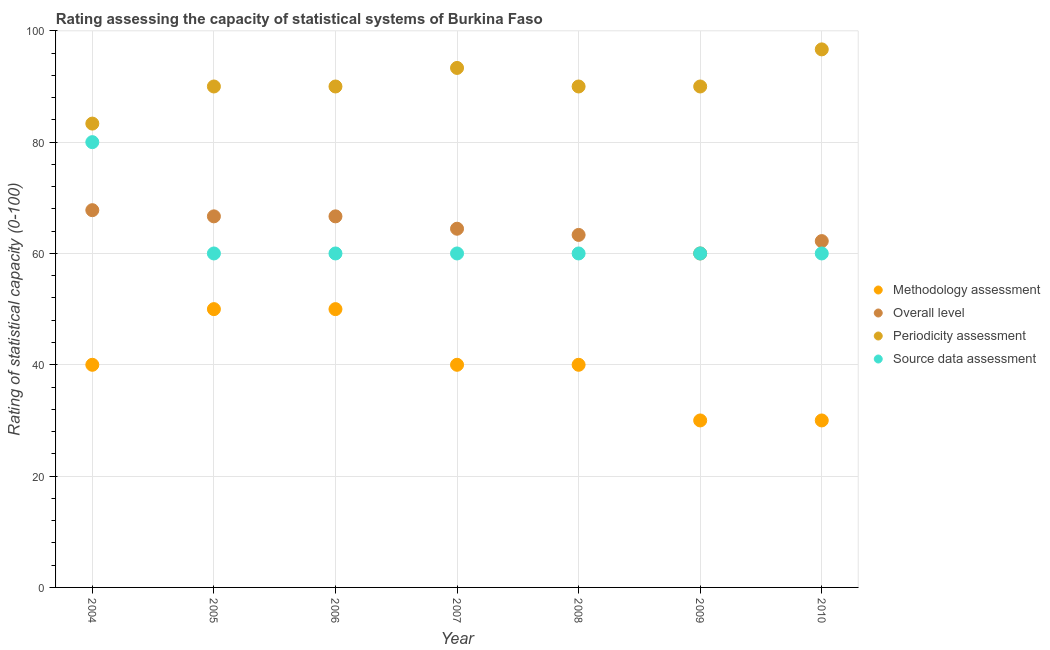Is the number of dotlines equal to the number of legend labels?
Offer a terse response. Yes. What is the periodicity assessment rating in 2008?
Your answer should be very brief. 90. Across all years, what is the maximum periodicity assessment rating?
Ensure brevity in your answer.  96.67. Across all years, what is the minimum methodology assessment rating?
Ensure brevity in your answer.  30. In which year was the source data assessment rating maximum?
Offer a terse response. 2004. In which year was the source data assessment rating minimum?
Your answer should be compact. 2005. What is the total periodicity assessment rating in the graph?
Offer a very short reply. 633.33. What is the difference between the methodology assessment rating in 2004 and that in 2006?
Offer a very short reply. -10. What is the difference between the methodology assessment rating in 2007 and the overall level rating in 2008?
Keep it short and to the point. -23.33. What is the average source data assessment rating per year?
Offer a very short reply. 62.86. In the year 2007, what is the difference between the overall level rating and source data assessment rating?
Give a very brief answer. 4.44. What is the difference between the highest and the second highest methodology assessment rating?
Offer a terse response. 0. What is the difference between the highest and the lowest source data assessment rating?
Make the answer very short. 20. In how many years, is the source data assessment rating greater than the average source data assessment rating taken over all years?
Offer a terse response. 1. Is the sum of the methodology assessment rating in 2006 and 2009 greater than the maximum source data assessment rating across all years?
Provide a short and direct response. No. Is the overall level rating strictly greater than the source data assessment rating over the years?
Ensure brevity in your answer.  No. How many dotlines are there?
Make the answer very short. 4. Does the graph contain any zero values?
Ensure brevity in your answer.  No. Does the graph contain grids?
Offer a terse response. Yes. Where does the legend appear in the graph?
Your answer should be compact. Center right. How many legend labels are there?
Give a very brief answer. 4. How are the legend labels stacked?
Give a very brief answer. Vertical. What is the title of the graph?
Provide a short and direct response. Rating assessing the capacity of statistical systems of Burkina Faso. What is the label or title of the Y-axis?
Offer a very short reply. Rating of statistical capacity (0-100). What is the Rating of statistical capacity (0-100) in Overall level in 2004?
Provide a succinct answer. 67.78. What is the Rating of statistical capacity (0-100) of Periodicity assessment in 2004?
Keep it short and to the point. 83.33. What is the Rating of statistical capacity (0-100) of Overall level in 2005?
Make the answer very short. 66.67. What is the Rating of statistical capacity (0-100) in Periodicity assessment in 2005?
Your answer should be compact. 90. What is the Rating of statistical capacity (0-100) of Source data assessment in 2005?
Make the answer very short. 60. What is the Rating of statistical capacity (0-100) in Overall level in 2006?
Provide a short and direct response. 66.67. What is the Rating of statistical capacity (0-100) of Periodicity assessment in 2006?
Offer a terse response. 90. What is the Rating of statistical capacity (0-100) of Source data assessment in 2006?
Offer a very short reply. 60. What is the Rating of statistical capacity (0-100) of Methodology assessment in 2007?
Keep it short and to the point. 40. What is the Rating of statistical capacity (0-100) in Overall level in 2007?
Offer a terse response. 64.44. What is the Rating of statistical capacity (0-100) of Periodicity assessment in 2007?
Your response must be concise. 93.33. What is the Rating of statistical capacity (0-100) in Overall level in 2008?
Provide a succinct answer. 63.33. What is the Rating of statistical capacity (0-100) of Methodology assessment in 2009?
Ensure brevity in your answer.  30. What is the Rating of statistical capacity (0-100) of Periodicity assessment in 2009?
Provide a short and direct response. 90. What is the Rating of statistical capacity (0-100) of Methodology assessment in 2010?
Offer a terse response. 30. What is the Rating of statistical capacity (0-100) of Overall level in 2010?
Provide a short and direct response. 62.22. What is the Rating of statistical capacity (0-100) in Periodicity assessment in 2010?
Provide a succinct answer. 96.67. Across all years, what is the maximum Rating of statistical capacity (0-100) of Methodology assessment?
Your response must be concise. 50. Across all years, what is the maximum Rating of statistical capacity (0-100) of Overall level?
Make the answer very short. 67.78. Across all years, what is the maximum Rating of statistical capacity (0-100) of Periodicity assessment?
Provide a short and direct response. 96.67. Across all years, what is the maximum Rating of statistical capacity (0-100) of Source data assessment?
Provide a succinct answer. 80. Across all years, what is the minimum Rating of statistical capacity (0-100) of Overall level?
Provide a succinct answer. 60. Across all years, what is the minimum Rating of statistical capacity (0-100) of Periodicity assessment?
Offer a very short reply. 83.33. Across all years, what is the minimum Rating of statistical capacity (0-100) of Source data assessment?
Provide a short and direct response. 60. What is the total Rating of statistical capacity (0-100) in Methodology assessment in the graph?
Provide a succinct answer. 280. What is the total Rating of statistical capacity (0-100) in Overall level in the graph?
Offer a terse response. 451.11. What is the total Rating of statistical capacity (0-100) of Periodicity assessment in the graph?
Offer a terse response. 633.33. What is the total Rating of statistical capacity (0-100) in Source data assessment in the graph?
Offer a very short reply. 440. What is the difference between the Rating of statistical capacity (0-100) of Methodology assessment in 2004 and that in 2005?
Your answer should be very brief. -10. What is the difference between the Rating of statistical capacity (0-100) of Overall level in 2004 and that in 2005?
Your answer should be compact. 1.11. What is the difference between the Rating of statistical capacity (0-100) of Periodicity assessment in 2004 and that in 2005?
Your answer should be very brief. -6.67. What is the difference between the Rating of statistical capacity (0-100) in Overall level in 2004 and that in 2006?
Offer a terse response. 1.11. What is the difference between the Rating of statistical capacity (0-100) of Periodicity assessment in 2004 and that in 2006?
Offer a very short reply. -6.67. What is the difference between the Rating of statistical capacity (0-100) in Source data assessment in 2004 and that in 2006?
Provide a succinct answer. 20. What is the difference between the Rating of statistical capacity (0-100) of Periodicity assessment in 2004 and that in 2007?
Your answer should be very brief. -10. What is the difference between the Rating of statistical capacity (0-100) in Overall level in 2004 and that in 2008?
Provide a succinct answer. 4.44. What is the difference between the Rating of statistical capacity (0-100) in Periodicity assessment in 2004 and that in 2008?
Offer a very short reply. -6.67. What is the difference between the Rating of statistical capacity (0-100) in Methodology assessment in 2004 and that in 2009?
Keep it short and to the point. 10. What is the difference between the Rating of statistical capacity (0-100) in Overall level in 2004 and that in 2009?
Your answer should be very brief. 7.78. What is the difference between the Rating of statistical capacity (0-100) in Periodicity assessment in 2004 and that in 2009?
Make the answer very short. -6.67. What is the difference between the Rating of statistical capacity (0-100) of Source data assessment in 2004 and that in 2009?
Offer a terse response. 20. What is the difference between the Rating of statistical capacity (0-100) in Methodology assessment in 2004 and that in 2010?
Make the answer very short. 10. What is the difference between the Rating of statistical capacity (0-100) of Overall level in 2004 and that in 2010?
Offer a very short reply. 5.56. What is the difference between the Rating of statistical capacity (0-100) of Periodicity assessment in 2004 and that in 2010?
Offer a terse response. -13.33. What is the difference between the Rating of statistical capacity (0-100) of Source data assessment in 2004 and that in 2010?
Offer a very short reply. 20. What is the difference between the Rating of statistical capacity (0-100) of Methodology assessment in 2005 and that in 2006?
Provide a short and direct response. 0. What is the difference between the Rating of statistical capacity (0-100) of Periodicity assessment in 2005 and that in 2006?
Give a very brief answer. 0. What is the difference between the Rating of statistical capacity (0-100) in Source data assessment in 2005 and that in 2006?
Make the answer very short. 0. What is the difference between the Rating of statistical capacity (0-100) in Methodology assessment in 2005 and that in 2007?
Your response must be concise. 10. What is the difference between the Rating of statistical capacity (0-100) in Overall level in 2005 and that in 2007?
Your answer should be very brief. 2.22. What is the difference between the Rating of statistical capacity (0-100) in Overall level in 2005 and that in 2008?
Offer a terse response. 3.33. What is the difference between the Rating of statistical capacity (0-100) in Methodology assessment in 2005 and that in 2009?
Your response must be concise. 20. What is the difference between the Rating of statistical capacity (0-100) in Overall level in 2005 and that in 2009?
Your response must be concise. 6.67. What is the difference between the Rating of statistical capacity (0-100) of Source data assessment in 2005 and that in 2009?
Offer a terse response. 0. What is the difference between the Rating of statistical capacity (0-100) of Methodology assessment in 2005 and that in 2010?
Offer a terse response. 20. What is the difference between the Rating of statistical capacity (0-100) in Overall level in 2005 and that in 2010?
Ensure brevity in your answer.  4.44. What is the difference between the Rating of statistical capacity (0-100) in Periodicity assessment in 2005 and that in 2010?
Your response must be concise. -6.67. What is the difference between the Rating of statistical capacity (0-100) of Source data assessment in 2005 and that in 2010?
Your answer should be compact. 0. What is the difference between the Rating of statistical capacity (0-100) of Overall level in 2006 and that in 2007?
Offer a very short reply. 2.22. What is the difference between the Rating of statistical capacity (0-100) in Periodicity assessment in 2006 and that in 2007?
Your answer should be very brief. -3.33. What is the difference between the Rating of statistical capacity (0-100) of Source data assessment in 2006 and that in 2007?
Provide a succinct answer. 0. What is the difference between the Rating of statistical capacity (0-100) in Methodology assessment in 2006 and that in 2008?
Your answer should be compact. 10. What is the difference between the Rating of statistical capacity (0-100) of Overall level in 2006 and that in 2008?
Provide a short and direct response. 3.33. What is the difference between the Rating of statistical capacity (0-100) in Periodicity assessment in 2006 and that in 2008?
Keep it short and to the point. 0. What is the difference between the Rating of statistical capacity (0-100) of Methodology assessment in 2006 and that in 2009?
Offer a terse response. 20. What is the difference between the Rating of statistical capacity (0-100) of Overall level in 2006 and that in 2009?
Your response must be concise. 6.67. What is the difference between the Rating of statistical capacity (0-100) in Periodicity assessment in 2006 and that in 2009?
Ensure brevity in your answer.  0. What is the difference between the Rating of statistical capacity (0-100) of Source data assessment in 2006 and that in 2009?
Your answer should be compact. 0. What is the difference between the Rating of statistical capacity (0-100) of Methodology assessment in 2006 and that in 2010?
Provide a short and direct response. 20. What is the difference between the Rating of statistical capacity (0-100) in Overall level in 2006 and that in 2010?
Offer a very short reply. 4.44. What is the difference between the Rating of statistical capacity (0-100) in Periodicity assessment in 2006 and that in 2010?
Provide a succinct answer. -6.67. What is the difference between the Rating of statistical capacity (0-100) in Overall level in 2007 and that in 2008?
Provide a succinct answer. 1.11. What is the difference between the Rating of statistical capacity (0-100) in Periodicity assessment in 2007 and that in 2008?
Ensure brevity in your answer.  3.33. What is the difference between the Rating of statistical capacity (0-100) in Overall level in 2007 and that in 2009?
Your answer should be very brief. 4.44. What is the difference between the Rating of statistical capacity (0-100) in Source data assessment in 2007 and that in 2009?
Offer a terse response. 0. What is the difference between the Rating of statistical capacity (0-100) in Overall level in 2007 and that in 2010?
Make the answer very short. 2.22. What is the difference between the Rating of statistical capacity (0-100) in Source data assessment in 2007 and that in 2010?
Offer a very short reply. 0. What is the difference between the Rating of statistical capacity (0-100) in Overall level in 2008 and that in 2010?
Provide a succinct answer. 1.11. What is the difference between the Rating of statistical capacity (0-100) in Periodicity assessment in 2008 and that in 2010?
Offer a terse response. -6.67. What is the difference between the Rating of statistical capacity (0-100) of Source data assessment in 2008 and that in 2010?
Your response must be concise. 0. What is the difference between the Rating of statistical capacity (0-100) of Methodology assessment in 2009 and that in 2010?
Provide a short and direct response. 0. What is the difference between the Rating of statistical capacity (0-100) in Overall level in 2009 and that in 2010?
Offer a terse response. -2.22. What is the difference between the Rating of statistical capacity (0-100) in Periodicity assessment in 2009 and that in 2010?
Make the answer very short. -6.67. What is the difference between the Rating of statistical capacity (0-100) of Methodology assessment in 2004 and the Rating of statistical capacity (0-100) of Overall level in 2005?
Make the answer very short. -26.67. What is the difference between the Rating of statistical capacity (0-100) in Overall level in 2004 and the Rating of statistical capacity (0-100) in Periodicity assessment in 2005?
Make the answer very short. -22.22. What is the difference between the Rating of statistical capacity (0-100) in Overall level in 2004 and the Rating of statistical capacity (0-100) in Source data assessment in 2005?
Your answer should be compact. 7.78. What is the difference between the Rating of statistical capacity (0-100) in Periodicity assessment in 2004 and the Rating of statistical capacity (0-100) in Source data assessment in 2005?
Offer a very short reply. 23.33. What is the difference between the Rating of statistical capacity (0-100) of Methodology assessment in 2004 and the Rating of statistical capacity (0-100) of Overall level in 2006?
Give a very brief answer. -26.67. What is the difference between the Rating of statistical capacity (0-100) in Overall level in 2004 and the Rating of statistical capacity (0-100) in Periodicity assessment in 2006?
Your response must be concise. -22.22. What is the difference between the Rating of statistical capacity (0-100) in Overall level in 2004 and the Rating of statistical capacity (0-100) in Source data assessment in 2006?
Provide a succinct answer. 7.78. What is the difference between the Rating of statistical capacity (0-100) of Periodicity assessment in 2004 and the Rating of statistical capacity (0-100) of Source data assessment in 2006?
Provide a succinct answer. 23.33. What is the difference between the Rating of statistical capacity (0-100) of Methodology assessment in 2004 and the Rating of statistical capacity (0-100) of Overall level in 2007?
Offer a very short reply. -24.44. What is the difference between the Rating of statistical capacity (0-100) in Methodology assessment in 2004 and the Rating of statistical capacity (0-100) in Periodicity assessment in 2007?
Keep it short and to the point. -53.33. What is the difference between the Rating of statistical capacity (0-100) in Overall level in 2004 and the Rating of statistical capacity (0-100) in Periodicity assessment in 2007?
Give a very brief answer. -25.56. What is the difference between the Rating of statistical capacity (0-100) in Overall level in 2004 and the Rating of statistical capacity (0-100) in Source data assessment in 2007?
Keep it short and to the point. 7.78. What is the difference between the Rating of statistical capacity (0-100) in Periodicity assessment in 2004 and the Rating of statistical capacity (0-100) in Source data assessment in 2007?
Offer a very short reply. 23.33. What is the difference between the Rating of statistical capacity (0-100) in Methodology assessment in 2004 and the Rating of statistical capacity (0-100) in Overall level in 2008?
Offer a terse response. -23.33. What is the difference between the Rating of statistical capacity (0-100) of Methodology assessment in 2004 and the Rating of statistical capacity (0-100) of Periodicity assessment in 2008?
Keep it short and to the point. -50. What is the difference between the Rating of statistical capacity (0-100) in Methodology assessment in 2004 and the Rating of statistical capacity (0-100) in Source data assessment in 2008?
Provide a succinct answer. -20. What is the difference between the Rating of statistical capacity (0-100) in Overall level in 2004 and the Rating of statistical capacity (0-100) in Periodicity assessment in 2008?
Keep it short and to the point. -22.22. What is the difference between the Rating of statistical capacity (0-100) in Overall level in 2004 and the Rating of statistical capacity (0-100) in Source data assessment in 2008?
Offer a very short reply. 7.78. What is the difference between the Rating of statistical capacity (0-100) of Periodicity assessment in 2004 and the Rating of statistical capacity (0-100) of Source data assessment in 2008?
Offer a very short reply. 23.33. What is the difference between the Rating of statistical capacity (0-100) in Methodology assessment in 2004 and the Rating of statistical capacity (0-100) in Overall level in 2009?
Provide a short and direct response. -20. What is the difference between the Rating of statistical capacity (0-100) in Overall level in 2004 and the Rating of statistical capacity (0-100) in Periodicity assessment in 2009?
Your answer should be compact. -22.22. What is the difference between the Rating of statistical capacity (0-100) in Overall level in 2004 and the Rating of statistical capacity (0-100) in Source data assessment in 2009?
Offer a terse response. 7.78. What is the difference between the Rating of statistical capacity (0-100) in Periodicity assessment in 2004 and the Rating of statistical capacity (0-100) in Source data assessment in 2009?
Offer a very short reply. 23.33. What is the difference between the Rating of statistical capacity (0-100) in Methodology assessment in 2004 and the Rating of statistical capacity (0-100) in Overall level in 2010?
Keep it short and to the point. -22.22. What is the difference between the Rating of statistical capacity (0-100) in Methodology assessment in 2004 and the Rating of statistical capacity (0-100) in Periodicity assessment in 2010?
Your answer should be compact. -56.67. What is the difference between the Rating of statistical capacity (0-100) of Overall level in 2004 and the Rating of statistical capacity (0-100) of Periodicity assessment in 2010?
Make the answer very short. -28.89. What is the difference between the Rating of statistical capacity (0-100) in Overall level in 2004 and the Rating of statistical capacity (0-100) in Source data assessment in 2010?
Provide a succinct answer. 7.78. What is the difference between the Rating of statistical capacity (0-100) in Periodicity assessment in 2004 and the Rating of statistical capacity (0-100) in Source data assessment in 2010?
Keep it short and to the point. 23.33. What is the difference between the Rating of statistical capacity (0-100) in Methodology assessment in 2005 and the Rating of statistical capacity (0-100) in Overall level in 2006?
Make the answer very short. -16.67. What is the difference between the Rating of statistical capacity (0-100) in Methodology assessment in 2005 and the Rating of statistical capacity (0-100) in Source data assessment in 2006?
Ensure brevity in your answer.  -10. What is the difference between the Rating of statistical capacity (0-100) of Overall level in 2005 and the Rating of statistical capacity (0-100) of Periodicity assessment in 2006?
Offer a very short reply. -23.33. What is the difference between the Rating of statistical capacity (0-100) in Periodicity assessment in 2005 and the Rating of statistical capacity (0-100) in Source data assessment in 2006?
Make the answer very short. 30. What is the difference between the Rating of statistical capacity (0-100) of Methodology assessment in 2005 and the Rating of statistical capacity (0-100) of Overall level in 2007?
Your response must be concise. -14.44. What is the difference between the Rating of statistical capacity (0-100) in Methodology assessment in 2005 and the Rating of statistical capacity (0-100) in Periodicity assessment in 2007?
Provide a succinct answer. -43.33. What is the difference between the Rating of statistical capacity (0-100) in Methodology assessment in 2005 and the Rating of statistical capacity (0-100) in Source data assessment in 2007?
Your answer should be compact. -10. What is the difference between the Rating of statistical capacity (0-100) in Overall level in 2005 and the Rating of statistical capacity (0-100) in Periodicity assessment in 2007?
Keep it short and to the point. -26.67. What is the difference between the Rating of statistical capacity (0-100) in Overall level in 2005 and the Rating of statistical capacity (0-100) in Source data assessment in 2007?
Your answer should be very brief. 6.67. What is the difference between the Rating of statistical capacity (0-100) in Methodology assessment in 2005 and the Rating of statistical capacity (0-100) in Overall level in 2008?
Make the answer very short. -13.33. What is the difference between the Rating of statistical capacity (0-100) of Overall level in 2005 and the Rating of statistical capacity (0-100) of Periodicity assessment in 2008?
Offer a very short reply. -23.33. What is the difference between the Rating of statistical capacity (0-100) of Methodology assessment in 2005 and the Rating of statistical capacity (0-100) of Overall level in 2009?
Make the answer very short. -10. What is the difference between the Rating of statistical capacity (0-100) of Methodology assessment in 2005 and the Rating of statistical capacity (0-100) of Source data assessment in 2009?
Keep it short and to the point. -10. What is the difference between the Rating of statistical capacity (0-100) in Overall level in 2005 and the Rating of statistical capacity (0-100) in Periodicity assessment in 2009?
Make the answer very short. -23.33. What is the difference between the Rating of statistical capacity (0-100) of Overall level in 2005 and the Rating of statistical capacity (0-100) of Source data assessment in 2009?
Provide a succinct answer. 6.67. What is the difference between the Rating of statistical capacity (0-100) of Methodology assessment in 2005 and the Rating of statistical capacity (0-100) of Overall level in 2010?
Offer a terse response. -12.22. What is the difference between the Rating of statistical capacity (0-100) of Methodology assessment in 2005 and the Rating of statistical capacity (0-100) of Periodicity assessment in 2010?
Provide a short and direct response. -46.67. What is the difference between the Rating of statistical capacity (0-100) in Methodology assessment in 2005 and the Rating of statistical capacity (0-100) in Source data assessment in 2010?
Provide a short and direct response. -10. What is the difference between the Rating of statistical capacity (0-100) in Periodicity assessment in 2005 and the Rating of statistical capacity (0-100) in Source data assessment in 2010?
Make the answer very short. 30. What is the difference between the Rating of statistical capacity (0-100) in Methodology assessment in 2006 and the Rating of statistical capacity (0-100) in Overall level in 2007?
Your answer should be compact. -14.44. What is the difference between the Rating of statistical capacity (0-100) of Methodology assessment in 2006 and the Rating of statistical capacity (0-100) of Periodicity assessment in 2007?
Ensure brevity in your answer.  -43.33. What is the difference between the Rating of statistical capacity (0-100) in Methodology assessment in 2006 and the Rating of statistical capacity (0-100) in Source data assessment in 2007?
Offer a terse response. -10. What is the difference between the Rating of statistical capacity (0-100) of Overall level in 2006 and the Rating of statistical capacity (0-100) of Periodicity assessment in 2007?
Keep it short and to the point. -26.67. What is the difference between the Rating of statistical capacity (0-100) in Overall level in 2006 and the Rating of statistical capacity (0-100) in Source data assessment in 2007?
Your answer should be very brief. 6.67. What is the difference between the Rating of statistical capacity (0-100) in Methodology assessment in 2006 and the Rating of statistical capacity (0-100) in Overall level in 2008?
Make the answer very short. -13.33. What is the difference between the Rating of statistical capacity (0-100) in Methodology assessment in 2006 and the Rating of statistical capacity (0-100) in Periodicity assessment in 2008?
Your answer should be compact. -40. What is the difference between the Rating of statistical capacity (0-100) in Overall level in 2006 and the Rating of statistical capacity (0-100) in Periodicity assessment in 2008?
Keep it short and to the point. -23.33. What is the difference between the Rating of statistical capacity (0-100) of Overall level in 2006 and the Rating of statistical capacity (0-100) of Source data assessment in 2008?
Make the answer very short. 6.67. What is the difference between the Rating of statistical capacity (0-100) in Periodicity assessment in 2006 and the Rating of statistical capacity (0-100) in Source data assessment in 2008?
Provide a succinct answer. 30. What is the difference between the Rating of statistical capacity (0-100) in Methodology assessment in 2006 and the Rating of statistical capacity (0-100) in Periodicity assessment in 2009?
Provide a short and direct response. -40. What is the difference between the Rating of statistical capacity (0-100) in Methodology assessment in 2006 and the Rating of statistical capacity (0-100) in Source data assessment in 2009?
Offer a very short reply. -10. What is the difference between the Rating of statistical capacity (0-100) in Overall level in 2006 and the Rating of statistical capacity (0-100) in Periodicity assessment in 2009?
Your answer should be compact. -23.33. What is the difference between the Rating of statistical capacity (0-100) of Methodology assessment in 2006 and the Rating of statistical capacity (0-100) of Overall level in 2010?
Offer a very short reply. -12.22. What is the difference between the Rating of statistical capacity (0-100) in Methodology assessment in 2006 and the Rating of statistical capacity (0-100) in Periodicity assessment in 2010?
Offer a very short reply. -46.67. What is the difference between the Rating of statistical capacity (0-100) of Methodology assessment in 2006 and the Rating of statistical capacity (0-100) of Source data assessment in 2010?
Your answer should be compact. -10. What is the difference between the Rating of statistical capacity (0-100) of Overall level in 2006 and the Rating of statistical capacity (0-100) of Source data assessment in 2010?
Offer a very short reply. 6.67. What is the difference between the Rating of statistical capacity (0-100) in Methodology assessment in 2007 and the Rating of statistical capacity (0-100) in Overall level in 2008?
Ensure brevity in your answer.  -23.33. What is the difference between the Rating of statistical capacity (0-100) of Methodology assessment in 2007 and the Rating of statistical capacity (0-100) of Periodicity assessment in 2008?
Keep it short and to the point. -50. What is the difference between the Rating of statistical capacity (0-100) in Overall level in 2007 and the Rating of statistical capacity (0-100) in Periodicity assessment in 2008?
Keep it short and to the point. -25.56. What is the difference between the Rating of statistical capacity (0-100) of Overall level in 2007 and the Rating of statistical capacity (0-100) of Source data assessment in 2008?
Your answer should be compact. 4.44. What is the difference between the Rating of statistical capacity (0-100) of Periodicity assessment in 2007 and the Rating of statistical capacity (0-100) of Source data assessment in 2008?
Offer a terse response. 33.33. What is the difference between the Rating of statistical capacity (0-100) in Methodology assessment in 2007 and the Rating of statistical capacity (0-100) in Overall level in 2009?
Ensure brevity in your answer.  -20. What is the difference between the Rating of statistical capacity (0-100) of Methodology assessment in 2007 and the Rating of statistical capacity (0-100) of Periodicity assessment in 2009?
Make the answer very short. -50. What is the difference between the Rating of statistical capacity (0-100) in Methodology assessment in 2007 and the Rating of statistical capacity (0-100) in Source data assessment in 2009?
Provide a succinct answer. -20. What is the difference between the Rating of statistical capacity (0-100) in Overall level in 2007 and the Rating of statistical capacity (0-100) in Periodicity assessment in 2009?
Make the answer very short. -25.56. What is the difference between the Rating of statistical capacity (0-100) of Overall level in 2007 and the Rating of statistical capacity (0-100) of Source data assessment in 2009?
Your response must be concise. 4.44. What is the difference between the Rating of statistical capacity (0-100) of Periodicity assessment in 2007 and the Rating of statistical capacity (0-100) of Source data assessment in 2009?
Offer a very short reply. 33.33. What is the difference between the Rating of statistical capacity (0-100) of Methodology assessment in 2007 and the Rating of statistical capacity (0-100) of Overall level in 2010?
Provide a succinct answer. -22.22. What is the difference between the Rating of statistical capacity (0-100) in Methodology assessment in 2007 and the Rating of statistical capacity (0-100) in Periodicity assessment in 2010?
Provide a succinct answer. -56.67. What is the difference between the Rating of statistical capacity (0-100) in Methodology assessment in 2007 and the Rating of statistical capacity (0-100) in Source data assessment in 2010?
Keep it short and to the point. -20. What is the difference between the Rating of statistical capacity (0-100) in Overall level in 2007 and the Rating of statistical capacity (0-100) in Periodicity assessment in 2010?
Provide a succinct answer. -32.22. What is the difference between the Rating of statistical capacity (0-100) of Overall level in 2007 and the Rating of statistical capacity (0-100) of Source data assessment in 2010?
Make the answer very short. 4.44. What is the difference between the Rating of statistical capacity (0-100) in Periodicity assessment in 2007 and the Rating of statistical capacity (0-100) in Source data assessment in 2010?
Make the answer very short. 33.33. What is the difference between the Rating of statistical capacity (0-100) in Methodology assessment in 2008 and the Rating of statistical capacity (0-100) in Periodicity assessment in 2009?
Offer a very short reply. -50. What is the difference between the Rating of statistical capacity (0-100) of Methodology assessment in 2008 and the Rating of statistical capacity (0-100) of Source data assessment in 2009?
Your response must be concise. -20. What is the difference between the Rating of statistical capacity (0-100) of Overall level in 2008 and the Rating of statistical capacity (0-100) of Periodicity assessment in 2009?
Offer a very short reply. -26.67. What is the difference between the Rating of statistical capacity (0-100) in Methodology assessment in 2008 and the Rating of statistical capacity (0-100) in Overall level in 2010?
Your answer should be compact. -22.22. What is the difference between the Rating of statistical capacity (0-100) of Methodology assessment in 2008 and the Rating of statistical capacity (0-100) of Periodicity assessment in 2010?
Provide a succinct answer. -56.67. What is the difference between the Rating of statistical capacity (0-100) of Methodology assessment in 2008 and the Rating of statistical capacity (0-100) of Source data assessment in 2010?
Provide a short and direct response. -20. What is the difference between the Rating of statistical capacity (0-100) of Overall level in 2008 and the Rating of statistical capacity (0-100) of Periodicity assessment in 2010?
Make the answer very short. -33.33. What is the difference between the Rating of statistical capacity (0-100) in Overall level in 2008 and the Rating of statistical capacity (0-100) in Source data assessment in 2010?
Your answer should be very brief. 3.33. What is the difference between the Rating of statistical capacity (0-100) of Methodology assessment in 2009 and the Rating of statistical capacity (0-100) of Overall level in 2010?
Offer a terse response. -32.22. What is the difference between the Rating of statistical capacity (0-100) in Methodology assessment in 2009 and the Rating of statistical capacity (0-100) in Periodicity assessment in 2010?
Offer a very short reply. -66.67. What is the difference between the Rating of statistical capacity (0-100) of Overall level in 2009 and the Rating of statistical capacity (0-100) of Periodicity assessment in 2010?
Your answer should be very brief. -36.67. What is the difference between the Rating of statistical capacity (0-100) of Overall level in 2009 and the Rating of statistical capacity (0-100) of Source data assessment in 2010?
Offer a terse response. 0. What is the difference between the Rating of statistical capacity (0-100) in Periodicity assessment in 2009 and the Rating of statistical capacity (0-100) in Source data assessment in 2010?
Your response must be concise. 30. What is the average Rating of statistical capacity (0-100) in Overall level per year?
Offer a very short reply. 64.44. What is the average Rating of statistical capacity (0-100) in Periodicity assessment per year?
Your response must be concise. 90.48. What is the average Rating of statistical capacity (0-100) of Source data assessment per year?
Keep it short and to the point. 62.86. In the year 2004, what is the difference between the Rating of statistical capacity (0-100) in Methodology assessment and Rating of statistical capacity (0-100) in Overall level?
Your response must be concise. -27.78. In the year 2004, what is the difference between the Rating of statistical capacity (0-100) in Methodology assessment and Rating of statistical capacity (0-100) in Periodicity assessment?
Offer a very short reply. -43.33. In the year 2004, what is the difference between the Rating of statistical capacity (0-100) in Methodology assessment and Rating of statistical capacity (0-100) in Source data assessment?
Keep it short and to the point. -40. In the year 2004, what is the difference between the Rating of statistical capacity (0-100) of Overall level and Rating of statistical capacity (0-100) of Periodicity assessment?
Make the answer very short. -15.56. In the year 2004, what is the difference between the Rating of statistical capacity (0-100) in Overall level and Rating of statistical capacity (0-100) in Source data assessment?
Offer a terse response. -12.22. In the year 2004, what is the difference between the Rating of statistical capacity (0-100) of Periodicity assessment and Rating of statistical capacity (0-100) of Source data assessment?
Provide a succinct answer. 3.33. In the year 2005, what is the difference between the Rating of statistical capacity (0-100) in Methodology assessment and Rating of statistical capacity (0-100) in Overall level?
Your answer should be very brief. -16.67. In the year 2005, what is the difference between the Rating of statistical capacity (0-100) in Methodology assessment and Rating of statistical capacity (0-100) in Source data assessment?
Your answer should be very brief. -10. In the year 2005, what is the difference between the Rating of statistical capacity (0-100) of Overall level and Rating of statistical capacity (0-100) of Periodicity assessment?
Give a very brief answer. -23.33. In the year 2005, what is the difference between the Rating of statistical capacity (0-100) in Overall level and Rating of statistical capacity (0-100) in Source data assessment?
Your response must be concise. 6.67. In the year 2005, what is the difference between the Rating of statistical capacity (0-100) in Periodicity assessment and Rating of statistical capacity (0-100) in Source data assessment?
Your answer should be compact. 30. In the year 2006, what is the difference between the Rating of statistical capacity (0-100) in Methodology assessment and Rating of statistical capacity (0-100) in Overall level?
Offer a very short reply. -16.67. In the year 2006, what is the difference between the Rating of statistical capacity (0-100) in Methodology assessment and Rating of statistical capacity (0-100) in Periodicity assessment?
Your response must be concise. -40. In the year 2006, what is the difference between the Rating of statistical capacity (0-100) of Methodology assessment and Rating of statistical capacity (0-100) of Source data assessment?
Offer a very short reply. -10. In the year 2006, what is the difference between the Rating of statistical capacity (0-100) in Overall level and Rating of statistical capacity (0-100) in Periodicity assessment?
Your answer should be compact. -23.33. In the year 2006, what is the difference between the Rating of statistical capacity (0-100) of Overall level and Rating of statistical capacity (0-100) of Source data assessment?
Ensure brevity in your answer.  6.67. In the year 2007, what is the difference between the Rating of statistical capacity (0-100) of Methodology assessment and Rating of statistical capacity (0-100) of Overall level?
Offer a terse response. -24.44. In the year 2007, what is the difference between the Rating of statistical capacity (0-100) in Methodology assessment and Rating of statistical capacity (0-100) in Periodicity assessment?
Provide a succinct answer. -53.33. In the year 2007, what is the difference between the Rating of statistical capacity (0-100) in Methodology assessment and Rating of statistical capacity (0-100) in Source data assessment?
Your answer should be compact. -20. In the year 2007, what is the difference between the Rating of statistical capacity (0-100) of Overall level and Rating of statistical capacity (0-100) of Periodicity assessment?
Keep it short and to the point. -28.89. In the year 2007, what is the difference between the Rating of statistical capacity (0-100) of Overall level and Rating of statistical capacity (0-100) of Source data assessment?
Offer a very short reply. 4.44. In the year 2007, what is the difference between the Rating of statistical capacity (0-100) in Periodicity assessment and Rating of statistical capacity (0-100) in Source data assessment?
Ensure brevity in your answer.  33.33. In the year 2008, what is the difference between the Rating of statistical capacity (0-100) in Methodology assessment and Rating of statistical capacity (0-100) in Overall level?
Provide a short and direct response. -23.33. In the year 2008, what is the difference between the Rating of statistical capacity (0-100) in Methodology assessment and Rating of statistical capacity (0-100) in Periodicity assessment?
Ensure brevity in your answer.  -50. In the year 2008, what is the difference between the Rating of statistical capacity (0-100) in Overall level and Rating of statistical capacity (0-100) in Periodicity assessment?
Ensure brevity in your answer.  -26.67. In the year 2008, what is the difference between the Rating of statistical capacity (0-100) of Overall level and Rating of statistical capacity (0-100) of Source data assessment?
Make the answer very short. 3.33. In the year 2008, what is the difference between the Rating of statistical capacity (0-100) in Periodicity assessment and Rating of statistical capacity (0-100) in Source data assessment?
Make the answer very short. 30. In the year 2009, what is the difference between the Rating of statistical capacity (0-100) in Methodology assessment and Rating of statistical capacity (0-100) in Periodicity assessment?
Provide a succinct answer. -60. In the year 2009, what is the difference between the Rating of statistical capacity (0-100) of Overall level and Rating of statistical capacity (0-100) of Periodicity assessment?
Ensure brevity in your answer.  -30. In the year 2009, what is the difference between the Rating of statistical capacity (0-100) of Overall level and Rating of statistical capacity (0-100) of Source data assessment?
Ensure brevity in your answer.  0. In the year 2010, what is the difference between the Rating of statistical capacity (0-100) of Methodology assessment and Rating of statistical capacity (0-100) of Overall level?
Make the answer very short. -32.22. In the year 2010, what is the difference between the Rating of statistical capacity (0-100) of Methodology assessment and Rating of statistical capacity (0-100) of Periodicity assessment?
Your response must be concise. -66.67. In the year 2010, what is the difference between the Rating of statistical capacity (0-100) in Methodology assessment and Rating of statistical capacity (0-100) in Source data assessment?
Offer a very short reply. -30. In the year 2010, what is the difference between the Rating of statistical capacity (0-100) of Overall level and Rating of statistical capacity (0-100) of Periodicity assessment?
Provide a short and direct response. -34.44. In the year 2010, what is the difference between the Rating of statistical capacity (0-100) in Overall level and Rating of statistical capacity (0-100) in Source data assessment?
Provide a succinct answer. 2.22. In the year 2010, what is the difference between the Rating of statistical capacity (0-100) of Periodicity assessment and Rating of statistical capacity (0-100) of Source data assessment?
Provide a succinct answer. 36.67. What is the ratio of the Rating of statistical capacity (0-100) of Overall level in 2004 to that in 2005?
Your answer should be very brief. 1.02. What is the ratio of the Rating of statistical capacity (0-100) in Periodicity assessment in 2004 to that in 2005?
Your response must be concise. 0.93. What is the ratio of the Rating of statistical capacity (0-100) of Overall level in 2004 to that in 2006?
Ensure brevity in your answer.  1.02. What is the ratio of the Rating of statistical capacity (0-100) of Periodicity assessment in 2004 to that in 2006?
Give a very brief answer. 0.93. What is the ratio of the Rating of statistical capacity (0-100) in Source data assessment in 2004 to that in 2006?
Keep it short and to the point. 1.33. What is the ratio of the Rating of statistical capacity (0-100) in Methodology assessment in 2004 to that in 2007?
Your response must be concise. 1. What is the ratio of the Rating of statistical capacity (0-100) in Overall level in 2004 to that in 2007?
Provide a succinct answer. 1.05. What is the ratio of the Rating of statistical capacity (0-100) in Periodicity assessment in 2004 to that in 2007?
Your response must be concise. 0.89. What is the ratio of the Rating of statistical capacity (0-100) in Source data assessment in 2004 to that in 2007?
Make the answer very short. 1.33. What is the ratio of the Rating of statistical capacity (0-100) in Methodology assessment in 2004 to that in 2008?
Offer a terse response. 1. What is the ratio of the Rating of statistical capacity (0-100) in Overall level in 2004 to that in 2008?
Your answer should be compact. 1.07. What is the ratio of the Rating of statistical capacity (0-100) of Periodicity assessment in 2004 to that in 2008?
Give a very brief answer. 0.93. What is the ratio of the Rating of statistical capacity (0-100) of Methodology assessment in 2004 to that in 2009?
Give a very brief answer. 1.33. What is the ratio of the Rating of statistical capacity (0-100) in Overall level in 2004 to that in 2009?
Give a very brief answer. 1.13. What is the ratio of the Rating of statistical capacity (0-100) in Periodicity assessment in 2004 to that in 2009?
Ensure brevity in your answer.  0.93. What is the ratio of the Rating of statistical capacity (0-100) of Methodology assessment in 2004 to that in 2010?
Keep it short and to the point. 1.33. What is the ratio of the Rating of statistical capacity (0-100) of Overall level in 2004 to that in 2010?
Offer a very short reply. 1.09. What is the ratio of the Rating of statistical capacity (0-100) of Periodicity assessment in 2004 to that in 2010?
Keep it short and to the point. 0.86. What is the ratio of the Rating of statistical capacity (0-100) in Overall level in 2005 to that in 2006?
Provide a succinct answer. 1. What is the ratio of the Rating of statistical capacity (0-100) of Periodicity assessment in 2005 to that in 2006?
Keep it short and to the point. 1. What is the ratio of the Rating of statistical capacity (0-100) in Overall level in 2005 to that in 2007?
Offer a very short reply. 1.03. What is the ratio of the Rating of statistical capacity (0-100) in Periodicity assessment in 2005 to that in 2007?
Your response must be concise. 0.96. What is the ratio of the Rating of statistical capacity (0-100) of Source data assessment in 2005 to that in 2007?
Your answer should be compact. 1. What is the ratio of the Rating of statistical capacity (0-100) of Overall level in 2005 to that in 2008?
Your answer should be very brief. 1.05. What is the ratio of the Rating of statistical capacity (0-100) in Overall level in 2005 to that in 2009?
Your response must be concise. 1.11. What is the ratio of the Rating of statistical capacity (0-100) in Periodicity assessment in 2005 to that in 2009?
Your answer should be very brief. 1. What is the ratio of the Rating of statistical capacity (0-100) in Overall level in 2005 to that in 2010?
Provide a succinct answer. 1.07. What is the ratio of the Rating of statistical capacity (0-100) in Periodicity assessment in 2005 to that in 2010?
Your response must be concise. 0.93. What is the ratio of the Rating of statistical capacity (0-100) of Source data assessment in 2005 to that in 2010?
Provide a short and direct response. 1. What is the ratio of the Rating of statistical capacity (0-100) in Overall level in 2006 to that in 2007?
Ensure brevity in your answer.  1.03. What is the ratio of the Rating of statistical capacity (0-100) in Source data assessment in 2006 to that in 2007?
Offer a very short reply. 1. What is the ratio of the Rating of statistical capacity (0-100) of Methodology assessment in 2006 to that in 2008?
Your answer should be compact. 1.25. What is the ratio of the Rating of statistical capacity (0-100) of Overall level in 2006 to that in 2008?
Offer a very short reply. 1.05. What is the ratio of the Rating of statistical capacity (0-100) of Periodicity assessment in 2006 to that in 2008?
Your answer should be compact. 1. What is the ratio of the Rating of statistical capacity (0-100) of Methodology assessment in 2006 to that in 2010?
Provide a succinct answer. 1.67. What is the ratio of the Rating of statistical capacity (0-100) of Overall level in 2006 to that in 2010?
Keep it short and to the point. 1.07. What is the ratio of the Rating of statistical capacity (0-100) of Methodology assessment in 2007 to that in 2008?
Make the answer very short. 1. What is the ratio of the Rating of statistical capacity (0-100) of Overall level in 2007 to that in 2008?
Offer a terse response. 1.02. What is the ratio of the Rating of statistical capacity (0-100) of Source data assessment in 2007 to that in 2008?
Offer a terse response. 1. What is the ratio of the Rating of statistical capacity (0-100) of Methodology assessment in 2007 to that in 2009?
Provide a short and direct response. 1.33. What is the ratio of the Rating of statistical capacity (0-100) of Overall level in 2007 to that in 2009?
Your response must be concise. 1.07. What is the ratio of the Rating of statistical capacity (0-100) in Overall level in 2007 to that in 2010?
Provide a succinct answer. 1.04. What is the ratio of the Rating of statistical capacity (0-100) in Periodicity assessment in 2007 to that in 2010?
Provide a short and direct response. 0.97. What is the ratio of the Rating of statistical capacity (0-100) of Overall level in 2008 to that in 2009?
Provide a short and direct response. 1.06. What is the ratio of the Rating of statistical capacity (0-100) of Periodicity assessment in 2008 to that in 2009?
Provide a short and direct response. 1. What is the ratio of the Rating of statistical capacity (0-100) in Methodology assessment in 2008 to that in 2010?
Offer a terse response. 1.33. What is the ratio of the Rating of statistical capacity (0-100) of Overall level in 2008 to that in 2010?
Make the answer very short. 1.02. What is the ratio of the Rating of statistical capacity (0-100) in Source data assessment in 2008 to that in 2010?
Provide a short and direct response. 1. What is the ratio of the Rating of statistical capacity (0-100) of Methodology assessment in 2009 to that in 2010?
Give a very brief answer. 1. What is the ratio of the Rating of statistical capacity (0-100) in Overall level in 2009 to that in 2010?
Your answer should be compact. 0.96. What is the difference between the highest and the second highest Rating of statistical capacity (0-100) in Methodology assessment?
Ensure brevity in your answer.  0. What is the difference between the highest and the lowest Rating of statistical capacity (0-100) in Methodology assessment?
Give a very brief answer. 20. What is the difference between the highest and the lowest Rating of statistical capacity (0-100) in Overall level?
Make the answer very short. 7.78. What is the difference between the highest and the lowest Rating of statistical capacity (0-100) of Periodicity assessment?
Keep it short and to the point. 13.33. 